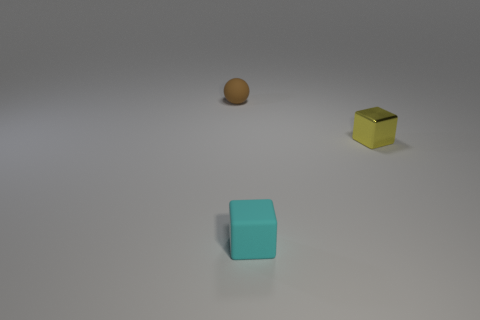What is the color of the rubber block?
Offer a very short reply. Cyan. What number of matte things are there?
Give a very brief answer. 2. There is a tiny rubber thing that is right of the small brown ball; is its shape the same as the tiny thing that is left of the rubber cube?
Make the answer very short. No. There is a rubber thing right of the matte object that is left of the tiny matte object on the right side of the brown object; what color is it?
Give a very brief answer. Cyan. The small thing in front of the yellow block is what color?
Your answer should be very brief. Cyan. There is a ball that is the same size as the yellow thing; what color is it?
Keep it short and to the point. Brown. Does the cyan object have the same size as the yellow thing?
Ensure brevity in your answer.  Yes. How many cubes are in front of the small shiny cube?
Make the answer very short. 1. What number of objects are tiny rubber things behind the cyan rubber thing or small cyan objects?
Your answer should be very brief. 2. Are there more brown balls right of the rubber sphere than tiny yellow metallic cubes that are behind the metallic thing?
Ensure brevity in your answer.  No. 